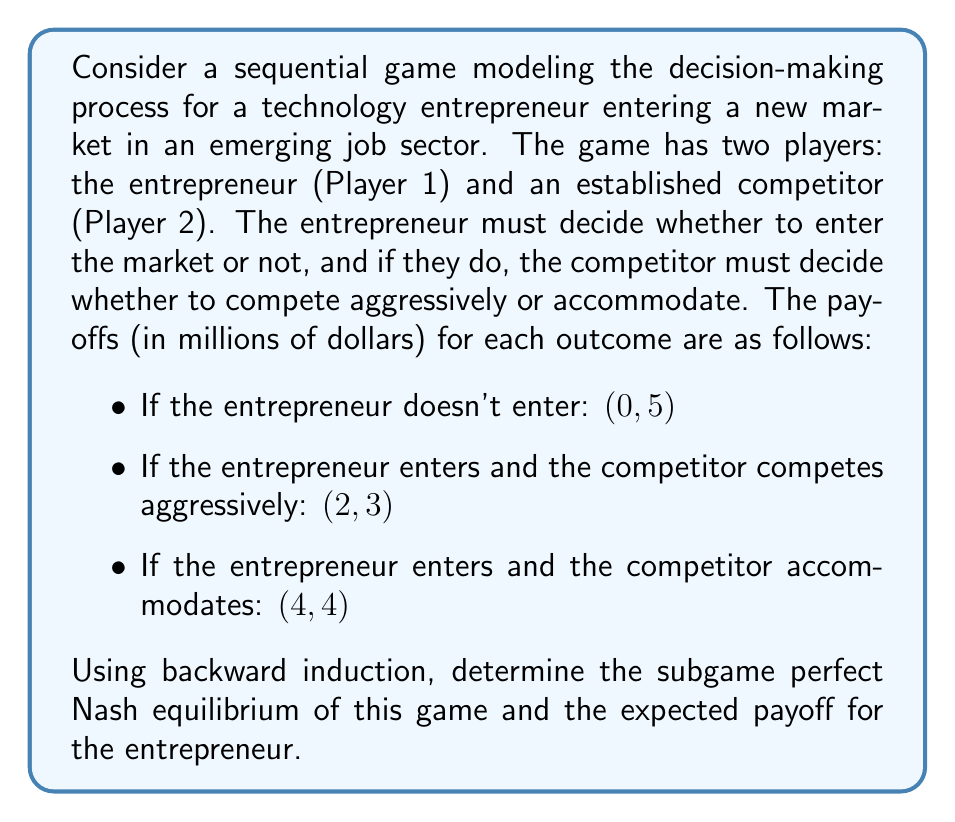Can you answer this question? To solve this sequential game and find the subgame perfect Nash equilibrium, we'll use backward induction. Let's break it down step by step:

1. Draw the game tree:

[asy]
unitsize(1cm);

draw((0,0)--(2,-1),arrow);
draw((0,0)--(2,1),arrow);
draw((2,1)--(4,2),arrow);
draw((2,1)--(4,0),arrow);

label("Entrepreneur", (0,0), W);
label("Don't Enter", (1,0.7), above);
label("Enter", (1,-0.7), below);
label("Competitor", (2,1), E);
label("Accommodate", (3,1.7), above);
label("Compete", (3,0.3), below);

label("(0,5)", (2,-1), E);
label("(4,4)", (4,2), E);
label("(2,3)", (4,0), E);
[/asy]

2. Start at the bottom of the tree (the competitor's decision):
   If the entrepreneur enters, the competitor must choose between:
   - Accommodate: payoff of 4
   - Compete aggressively: payoff of 3
   
   The competitor will choose to accommodate as it yields a higher payoff (4 > 3).

3. Move up the tree to the entrepreneur's decision:
   The entrepreneur must choose between:
   - Don't enter: payoff of 0
   - Enter: Since we know the competitor will accommodate, the payoff is 4
   
   The entrepreneur will choose to enter as it yields a higher payoff (4 > 0).

4. The subgame perfect Nash equilibrium is therefore:
   (Enter, Accommodate)

5. The expected payoff for the entrepreneur in this equilibrium is $4 million.

This solution demonstrates how data analysis can be used to model decision-making in emerging markets, which is relevant to the persona of a technology entrepreneur utilizing data analysis to identify emerging job sectors.
Answer: The subgame perfect Nash equilibrium is (Enter, Accommodate), and the expected payoff for the entrepreneur is $4 million. 